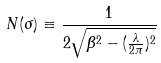Convert formula to latex. <formula><loc_0><loc_0><loc_500><loc_500>N ( \sigma ) \equiv \frac { 1 } { 2 \sqrt { \beta ^ { 2 } - ( \frac { \lambda } { 2 \pi } ) ^ { 2 } } }</formula> 